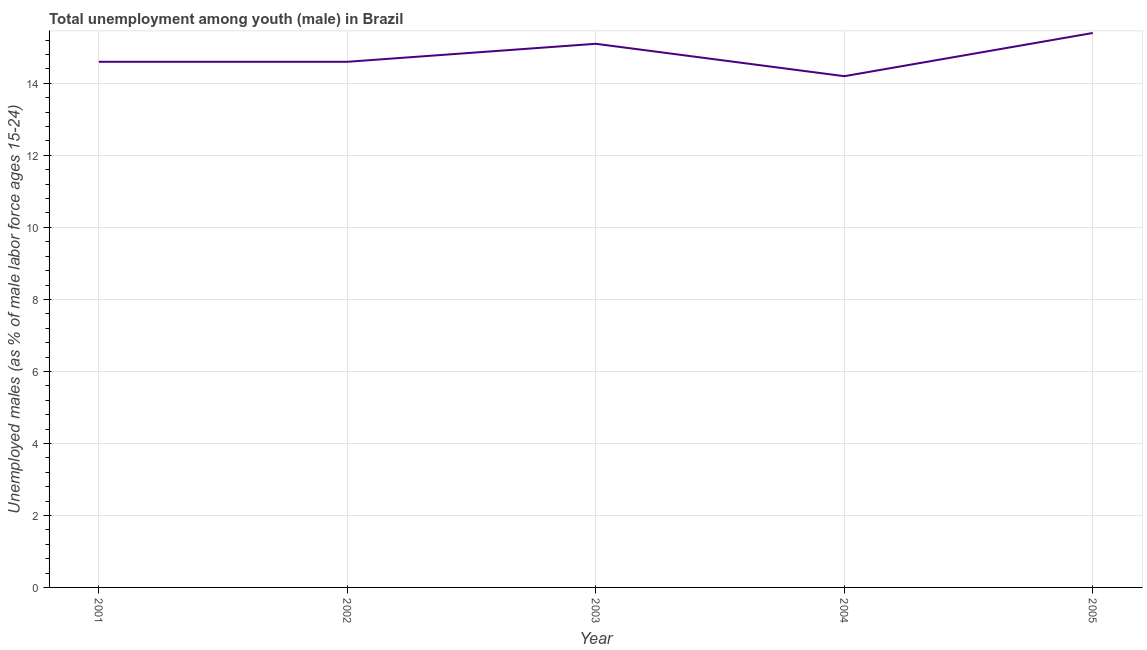What is the unemployed male youth population in 2002?
Provide a short and direct response. 14.6. Across all years, what is the maximum unemployed male youth population?
Provide a succinct answer. 15.4. Across all years, what is the minimum unemployed male youth population?
Offer a very short reply. 14.2. What is the sum of the unemployed male youth population?
Your answer should be very brief. 73.9. What is the difference between the unemployed male youth population in 2002 and 2004?
Give a very brief answer. 0.4. What is the average unemployed male youth population per year?
Your answer should be compact. 14.78. What is the median unemployed male youth population?
Ensure brevity in your answer.  14.6. What is the ratio of the unemployed male youth population in 2003 to that in 2005?
Your answer should be very brief. 0.98. Is the difference between the unemployed male youth population in 2001 and 2002 greater than the difference between any two years?
Keep it short and to the point. No. What is the difference between the highest and the second highest unemployed male youth population?
Offer a very short reply. 0.3. Is the sum of the unemployed male youth population in 2001 and 2003 greater than the maximum unemployed male youth population across all years?
Give a very brief answer. Yes. What is the difference between the highest and the lowest unemployed male youth population?
Make the answer very short. 1.2. In how many years, is the unemployed male youth population greater than the average unemployed male youth population taken over all years?
Your answer should be compact. 2. How many lines are there?
Make the answer very short. 1. How many years are there in the graph?
Offer a terse response. 5. What is the difference between two consecutive major ticks on the Y-axis?
Your answer should be very brief. 2. Does the graph contain grids?
Offer a terse response. Yes. What is the title of the graph?
Provide a succinct answer. Total unemployment among youth (male) in Brazil. What is the label or title of the X-axis?
Keep it short and to the point. Year. What is the label or title of the Y-axis?
Your answer should be compact. Unemployed males (as % of male labor force ages 15-24). What is the Unemployed males (as % of male labor force ages 15-24) in 2001?
Give a very brief answer. 14.6. What is the Unemployed males (as % of male labor force ages 15-24) in 2002?
Offer a terse response. 14.6. What is the Unemployed males (as % of male labor force ages 15-24) of 2003?
Offer a very short reply. 15.1. What is the Unemployed males (as % of male labor force ages 15-24) in 2004?
Ensure brevity in your answer.  14.2. What is the Unemployed males (as % of male labor force ages 15-24) in 2005?
Offer a terse response. 15.4. What is the difference between the Unemployed males (as % of male labor force ages 15-24) in 2003 and 2005?
Give a very brief answer. -0.3. What is the ratio of the Unemployed males (as % of male labor force ages 15-24) in 2001 to that in 2004?
Ensure brevity in your answer.  1.03. What is the ratio of the Unemployed males (as % of male labor force ages 15-24) in 2001 to that in 2005?
Offer a very short reply. 0.95. What is the ratio of the Unemployed males (as % of male labor force ages 15-24) in 2002 to that in 2004?
Make the answer very short. 1.03. What is the ratio of the Unemployed males (as % of male labor force ages 15-24) in 2002 to that in 2005?
Give a very brief answer. 0.95. What is the ratio of the Unemployed males (as % of male labor force ages 15-24) in 2003 to that in 2004?
Give a very brief answer. 1.06. What is the ratio of the Unemployed males (as % of male labor force ages 15-24) in 2004 to that in 2005?
Provide a succinct answer. 0.92. 